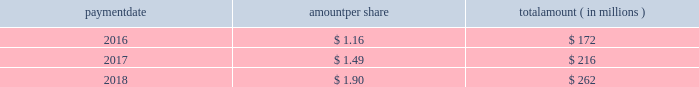Humana inc .
Notes to consolidated financial statements 2014 ( continued ) 15 .
Stockholders 2019 equity dividends the table provides details of dividend payments , excluding dividend equivalent rights , in 2016 , 2017 , and 2018 under our board approved quarterly cash dividend policy : payment amount per share amount ( in millions ) .
On november 2 , 2018 , the board declared a cash dividend of $ 0.50 per share that was paid on january 25 , 2019 to stockholders of record on december 31 , 2018 , for an aggregate amount of $ 68 million .
Declaration and payment of future quarterly dividends is at the discretion of our board and may be adjusted as business needs or market conditions change .
In february 2019 , the board declared a cash dividend of $ 0.55 per share payable on april 26 , 2019 to stockholders of record on march 29 , 2019 .
Stock repurchases our board of directors may authorize the purchase of our common shares .
Under our share repurchase authorization , shares may have been purchased from time to time at prevailing prices in the open market , by block purchases , through plans designed to comply with rule 10b5-1 under the securities exchange act of 1934 , as amended , or in privately-negotiated transactions ( including pursuant to accelerated share repurchase agreements with investment banks ) , subject to certain regulatory restrictions on volume , pricing , and timing .
On february 14 , 2017 , our board of directors authorized the repurchase of up to $ 2.25 billion of our common shares expiring on december 31 , 2017 , exclusive of shares repurchased in connection with employee stock plans .
On february 16 , 2017 , we entered into an accelerated share repurchase agreement , the february 2017 asr , with goldman , sachs & co .
Llc , or goldman sachs , to repurchase $ 1.5 billion of our common stock as part of the $ 2.25 billion share repurchase authorized on february 14 , 2017 .
On february 22 , 2017 , we made a payment of $ 1.5 billion to goldman sachs from available cash on hand and received an initial delivery of 5.83 million shares of our common stock from goldman sachs based on the then current market price of humana common stock .
The payment to goldman sachs was recorded as a reduction to stockholders 2019 equity , consisting of a $ 1.2 billion increase in treasury stock , which reflected the value of the initial 5.83 million shares received upon initial settlement , and a $ 300 million decrease in capital in excess of par value , which reflected the value of stock held back by goldman sachs pending final settlement of the february 2017 asr .
Upon settlement of the february 2017 asr on august 28 , 2017 , we received an additional 0.84 million shares as determined by the average daily volume weighted-average share price of our common stock during the term of the agreement of $ 224.81 , less a discount and subject to adjustments pursuant to the terms and conditions of the february 2017 asr , bringing the total shares received under this program to 6.67 million .
In addition , upon settlement we reclassified the $ 300 million value of stock initially held back by goldman sachs from capital in excess of par value to treasury stock .
Subsequent to settlement of the february 2017 asr , we repurchased an additional 3.04 million shares in the open market , utilizing the remaining $ 750 million of the $ 2.25 billion authorization prior to expiration .
On december 14 , 2017 , our board of directors authorized the repurchase of up to $ 3.0 billion of our common shares expiring on december 31 , 2020 , exclusive of shares repurchased in connection with employee stock plans. .
What was the amount of shares paid out in 2016 in millions? 
Rationale: 1.48 million shares were paid out in 2016
Computations: (172 / 1.16)
Answer: 148.27586. 